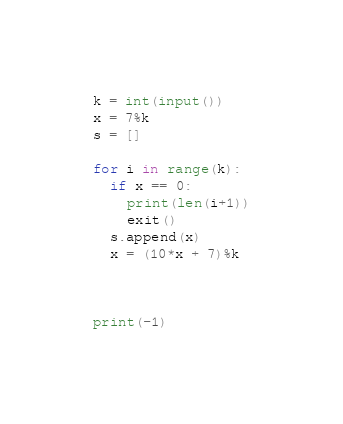Convert code to text. <code><loc_0><loc_0><loc_500><loc_500><_Python_>k = int(input())
x = 7%k
s = []

for i in range(k):
  if x == 0:
    print(len(i+1))
    exit()
  s.append(x)
  x = (10*x + 7)%k

  
  
print(-1)
</code> 